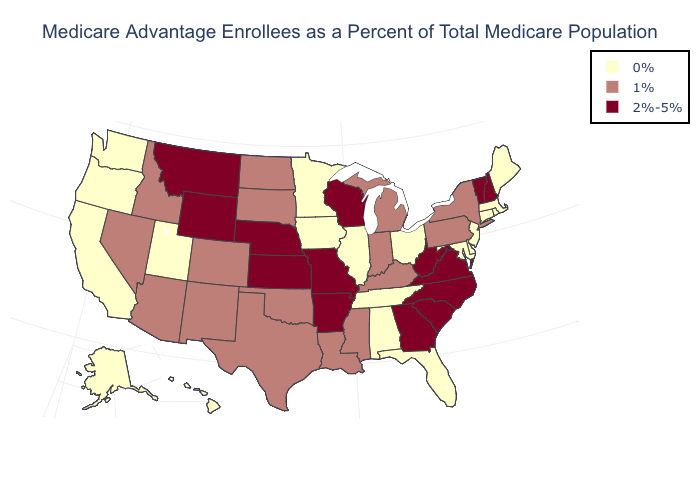Does California have the lowest value in the USA?
Answer briefly. Yes. Does the first symbol in the legend represent the smallest category?
Be succinct. Yes. Name the states that have a value in the range 2%-5%?
Write a very short answer. Arkansas, Georgia, Kansas, Missouri, Montana, North Carolina, Nebraska, New Hampshire, South Carolina, Virginia, Vermont, Wisconsin, West Virginia, Wyoming. What is the value of Mississippi?
Concise answer only. 1%. Name the states that have a value in the range 1%?
Give a very brief answer. Arizona, Colorado, Idaho, Indiana, Kentucky, Louisiana, Michigan, Mississippi, North Dakota, New Mexico, Nevada, New York, Oklahoma, Pennsylvania, South Dakota, Texas. What is the value of Tennessee?
Answer briefly. 0%. Name the states that have a value in the range 2%-5%?
Short answer required. Arkansas, Georgia, Kansas, Missouri, Montana, North Carolina, Nebraska, New Hampshire, South Carolina, Virginia, Vermont, Wisconsin, West Virginia, Wyoming. What is the value of Minnesota?
Be succinct. 0%. What is the highest value in states that border New York?
Quick response, please. 2%-5%. Which states have the lowest value in the West?
Be succinct. Alaska, California, Hawaii, Oregon, Utah, Washington. Does the map have missing data?
Be succinct. No. Does Arkansas have the highest value in the South?
Answer briefly. Yes. What is the highest value in the USA?
Be succinct. 2%-5%. What is the value of Colorado?
Write a very short answer. 1%. What is the highest value in the MidWest ?
Give a very brief answer. 2%-5%. 